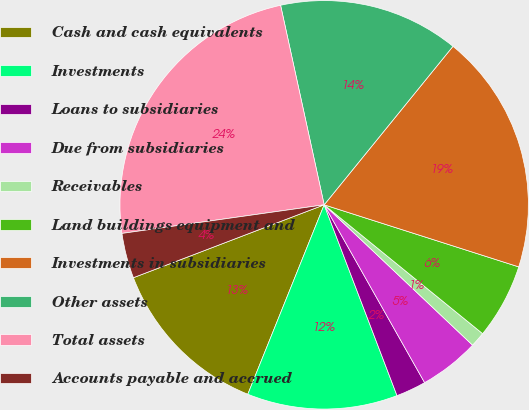Convert chart. <chart><loc_0><loc_0><loc_500><loc_500><pie_chart><fcel>Cash and cash equivalents<fcel>Investments<fcel>Loans to subsidiaries<fcel>Due from subsidiaries<fcel>Receivables<fcel>Land buildings equipment and<fcel>Investments in subsidiaries<fcel>Other assets<fcel>Total assets<fcel>Accounts payable and accrued<nl><fcel>13.09%<fcel>11.9%<fcel>2.38%<fcel>4.76%<fcel>1.19%<fcel>5.95%<fcel>19.05%<fcel>14.28%<fcel>23.81%<fcel>3.57%<nl></chart> 